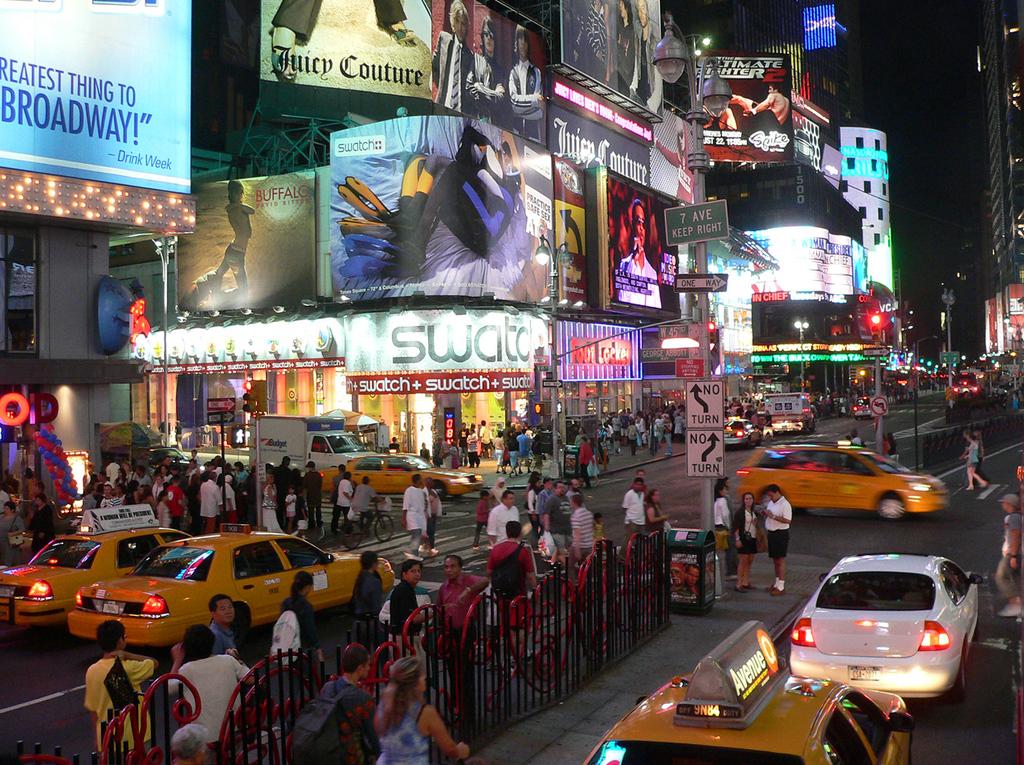Who was quoted as saying "the greatest thing to broadway!"?
Your response must be concise. Drink week. What watch company is shown above the moving truck?
Make the answer very short. Swatch. 